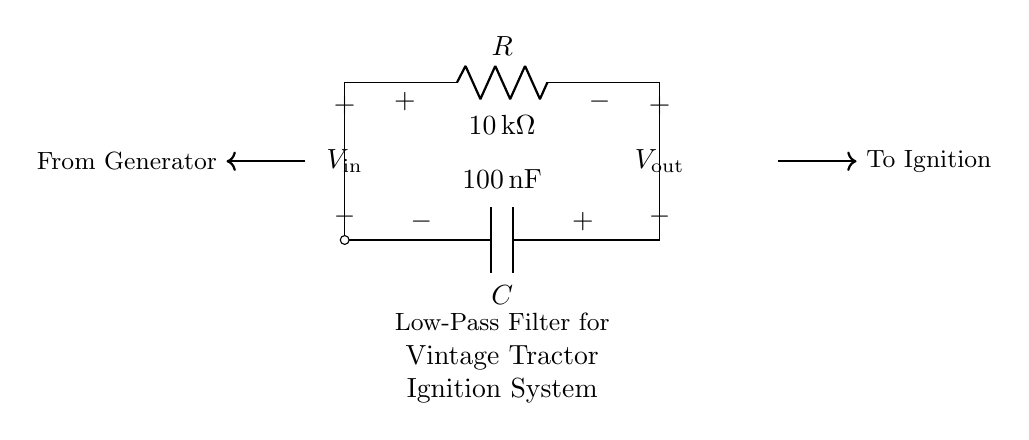What components are used in this circuit? The circuit uses a resistor and a capacitor, which are essential components for a low-pass filter configuration.
Answer: resistor and capacitor What is the resistance value in the circuit? The value of the resistor is clearly labeled in the diagram as ten kilo-ohms.
Answer: ten kilo-ohms What capacitance value does the circuit use? The capacitor value is indicated in the circuit diagram as one hundred nanofarads.
Answer: one hundred nanofarads What is the purpose of this circuit? The circuit is designed as a low-pass filter specifically for vintage tractor ignition systems, to reduce interference.
Answer: reduce interference Why does the circuit need to protect the ignition system? The ignition system is sensitive to high-frequency signals that can interfere with its operation, thus the low-pass filter allows only the desired low frequencies to pass.
Answer: to prevent interference How does the current flow in this circuit? Current flows from the generator to the resistor and capacitor, while the output is taken after the resistor, which filters out high-frequency noise.
Answer: from generator to ignition What type of circuit is demonstrated here? The circuit is a low-pass filter, which is specifically designed to allow low frequencies to pass while attenuating higher frequencies.
Answer: low-pass filter 